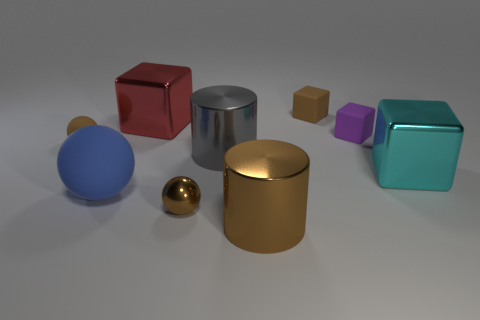Subtract all purple cubes. Subtract all red spheres. How many cubes are left? 3 Add 1 spheres. How many objects exist? 10 Subtract all cubes. How many objects are left? 5 Add 9 big blue spheres. How many big blue spheres are left? 10 Add 6 small brown things. How many small brown things exist? 9 Subtract 1 brown cylinders. How many objects are left? 8 Subtract all tiny matte spheres. Subtract all big metal cubes. How many objects are left? 6 